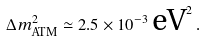Convert formula to latex. <formula><loc_0><loc_0><loc_500><loc_500>\Delta { m } ^ { 2 } _ { \text {ATM} } \simeq 2 . 5 \times 1 0 ^ { - 3 } \, \text {eV} ^ { 2 } \, .</formula> 